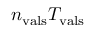Convert formula to latex. <formula><loc_0><loc_0><loc_500><loc_500>n _ { v a l s } T _ { v a l s }</formula> 